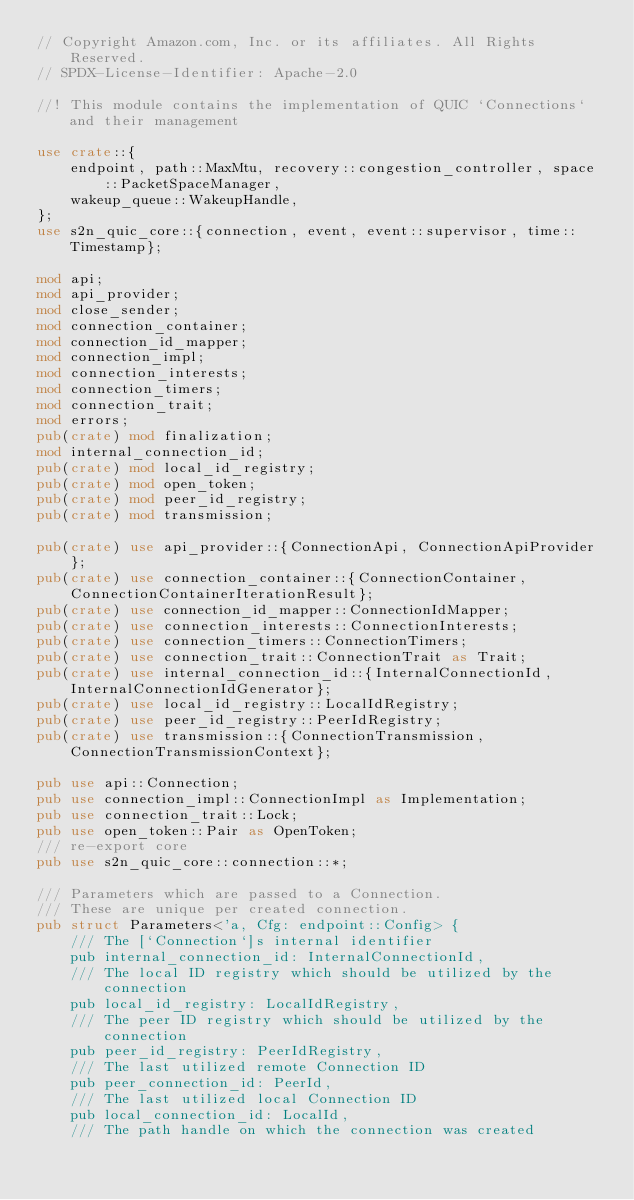Convert code to text. <code><loc_0><loc_0><loc_500><loc_500><_Rust_>// Copyright Amazon.com, Inc. or its affiliates. All Rights Reserved.
// SPDX-License-Identifier: Apache-2.0

//! This module contains the implementation of QUIC `Connections` and their management

use crate::{
    endpoint, path::MaxMtu, recovery::congestion_controller, space::PacketSpaceManager,
    wakeup_queue::WakeupHandle,
};
use s2n_quic_core::{connection, event, event::supervisor, time::Timestamp};

mod api;
mod api_provider;
mod close_sender;
mod connection_container;
mod connection_id_mapper;
mod connection_impl;
mod connection_interests;
mod connection_timers;
mod connection_trait;
mod errors;
pub(crate) mod finalization;
mod internal_connection_id;
pub(crate) mod local_id_registry;
pub(crate) mod open_token;
pub(crate) mod peer_id_registry;
pub(crate) mod transmission;

pub(crate) use api_provider::{ConnectionApi, ConnectionApiProvider};
pub(crate) use connection_container::{ConnectionContainer, ConnectionContainerIterationResult};
pub(crate) use connection_id_mapper::ConnectionIdMapper;
pub(crate) use connection_interests::ConnectionInterests;
pub(crate) use connection_timers::ConnectionTimers;
pub(crate) use connection_trait::ConnectionTrait as Trait;
pub(crate) use internal_connection_id::{InternalConnectionId, InternalConnectionIdGenerator};
pub(crate) use local_id_registry::LocalIdRegistry;
pub(crate) use peer_id_registry::PeerIdRegistry;
pub(crate) use transmission::{ConnectionTransmission, ConnectionTransmissionContext};

pub use api::Connection;
pub use connection_impl::ConnectionImpl as Implementation;
pub use connection_trait::Lock;
pub use open_token::Pair as OpenToken;
/// re-export core
pub use s2n_quic_core::connection::*;

/// Parameters which are passed to a Connection.
/// These are unique per created connection.
pub struct Parameters<'a, Cfg: endpoint::Config> {
    /// The [`Connection`]s internal identifier
    pub internal_connection_id: InternalConnectionId,
    /// The local ID registry which should be utilized by the connection
    pub local_id_registry: LocalIdRegistry,
    /// The peer ID registry which should be utilized by the connection
    pub peer_id_registry: PeerIdRegistry,
    /// The last utilized remote Connection ID
    pub peer_connection_id: PeerId,
    /// The last utilized local Connection ID
    pub local_connection_id: LocalId,
    /// The path handle on which the connection was created</code> 